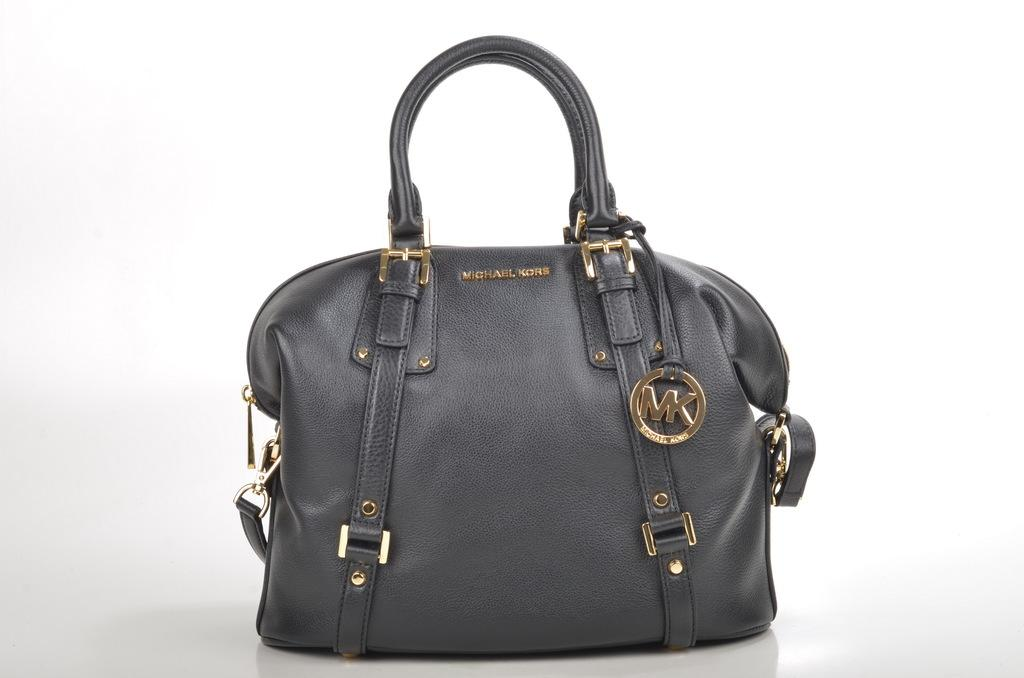What type of accessory is in the picture? There is a handbag in the picture. What is the color of the handbag? The handbag is black in color. What brand is the handbag? The text "Michael Kors" is printed on the handbag. What logo is on the handbag? The handbag has a logo MK. What features does the handbag have for opening and closing? The handbag has zips. What type of fasteners are on the handles of the handbag? The handbag has buckles at the handles. What type of feather is used to decorate the handbag in the image? There are no feathers present on the handbag in the image. What type of calendar is visible inside the handbag in the image? There is no calendar visible inside the handbag in the image. 